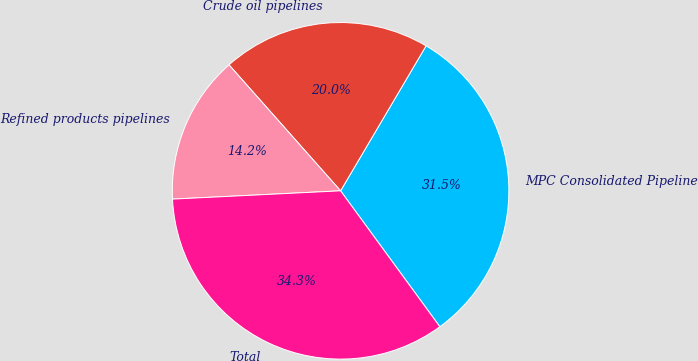Convert chart to OTSL. <chart><loc_0><loc_0><loc_500><loc_500><pie_chart><fcel>MPC Consolidated Pipeline<fcel>Crude oil pipelines<fcel>Refined products pipelines<fcel>Total<nl><fcel>31.48%<fcel>20.02%<fcel>14.25%<fcel>34.26%<nl></chart> 